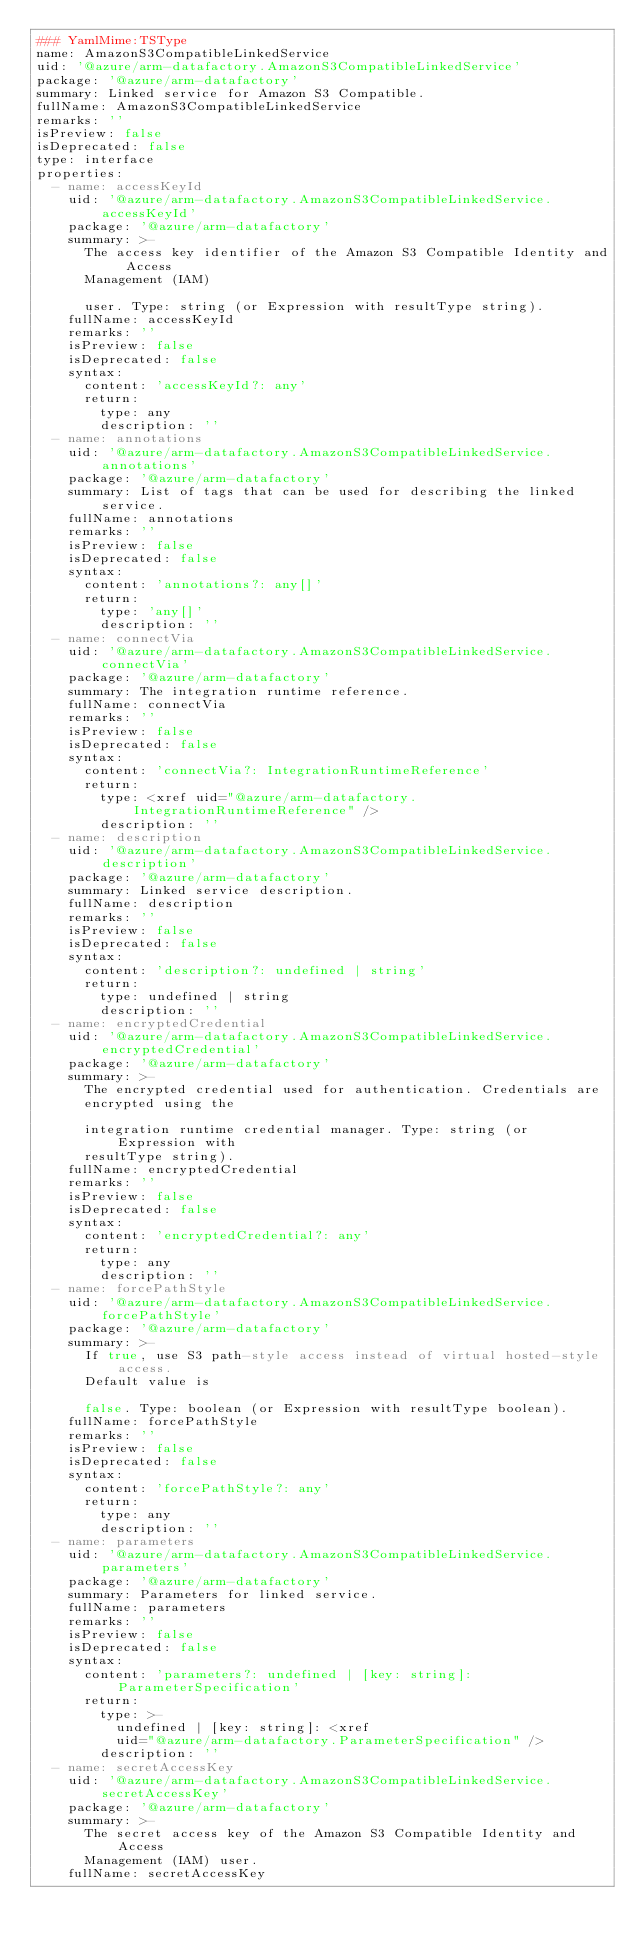<code> <loc_0><loc_0><loc_500><loc_500><_YAML_>### YamlMime:TSType
name: AmazonS3CompatibleLinkedService
uid: '@azure/arm-datafactory.AmazonS3CompatibleLinkedService'
package: '@azure/arm-datafactory'
summary: Linked service for Amazon S3 Compatible.
fullName: AmazonS3CompatibleLinkedService
remarks: ''
isPreview: false
isDeprecated: false
type: interface
properties:
  - name: accessKeyId
    uid: '@azure/arm-datafactory.AmazonS3CompatibleLinkedService.accessKeyId'
    package: '@azure/arm-datafactory'
    summary: >-
      The access key identifier of the Amazon S3 Compatible Identity and Access
      Management (IAM)

      user. Type: string (or Expression with resultType string).
    fullName: accessKeyId
    remarks: ''
    isPreview: false
    isDeprecated: false
    syntax:
      content: 'accessKeyId?: any'
      return:
        type: any
        description: ''
  - name: annotations
    uid: '@azure/arm-datafactory.AmazonS3CompatibleLinkedService.annotations'
    package: '@azure/arm-datafactory'
    summary: List of tags that can be used for describing the linked service.
    fullName: annotations
    remarks: ''
    isPreview: false
    isDeprecated: false
    syntax:
      content: 'annotations?: any[]'
      return:
        type: 'any[]'
        description: ''
  - name: connectVia
    uid: '@azure/arm-datafactory.AmazonS3CompatibleLinkedService.connectVia'
    package: '@azure/arm-datafactory'
    summary: The integration runtime reference.
    fullName: connectVia
    remarks: ''
    isPreview: false
    isDeprecated: false
    syntax:
      content: 'connectVia?: IntegrationRuntimeReference'
      return:
        type: <xref uid="@azure/arm-datafactory.IntegrationRuntimeReference" />
        description: ''
  - name: description
    uid: '@azure/arm-datafactory.AmazonS3CompatibleLinkedService.description'
    package: '@azure/arm-datafactory'
    summary: Linked service description.
    fullName: description
    remarks: ''
    isPreview: false
    isDeprecated: false
    syntax:
      content: 'description?: undefined | string'
      return:
        type: undefined | string
        description: ''
  - name: encryptedCredential
    uid: '@azure/arm-datafactory.AmazonS3CompatibleLinkedService.encryptedCredential'
    package: '@azure/arm-datafactory'
    summary: >-
      The encrypted credential used for authentication. Credentials are
      encrypted using the

      integration runtime credential manager. Type: string (or Expression with
      resultType string).
    fullName: encryptedCredential
    remarks: ''
    isPreview: false
    isDeprecated: false
    syntax:
      content: 'encryptedCredential?: any'
      return:
        type: any
        description: ''
  - name: forcePathStyle
    uid: '@azure/arm-datafactory.AmazonS3CompatibleLinkedService.forcePathStyle'
    package: '@azure/arm-datafactory'
    summary: >-
      If true, use S3 path-style access instead of virtual hosted-style access.
      Default value is

      false. Type: boolean (or Expression with resultType boolean).
    fullName: forcePathStyle
    remarks: ''
    isPreview: false
    isDeprecated: false
    syntax:
      content: 'forcePathStyle?: any'
      return:
        type: any
        description: ''
  - name: parameters
    uid: '@azure/arm-datafactory.AmazonS3CompatibleLinkedService.parameters'
    package: '@azure/arm-datafactory'
    summary: Parameters for linked service.
    fullName: parameters
    remarks: ''
    isPreview: false
    isDeprecated: false
    syntax:
      content: 'parameters?: undefined | [key: string]: ParameterSpecification'
      return:
        type: >-
          undefined | [key: string]: <xref
          uid="@azure/arm-datafactory.ParameterSpecification" />
        description: ''
  - name: secretAccessKey
    uid: '@azure/arm-datafactory.AmazonS3CompatibleLinkedService.secretAccessKey'
    package: '@azure/arm-datafactory'
    summary: >-
      The secret access key of the Amazon S3 Compatible Identity and Access
      Management (IAM) user.
    fullName: secretAccessKey</code> 